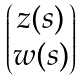Convert formula to latex. <formula><loc_0><loc_0><loc_500><loc_500>\begin{pmatrix} z ( s ) \\ w ( s ) \end{pmatrix}</formula> 